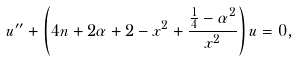Convert formula to latex. <formula><loc_0><loc_0><loc_500><loc_500>u ^ { \prime \prime } + \left ( 4 n + 2 \alpha + 2 - x ^ { 2 } + \frac { \frac { 1 } { 4 } - \alpha ^ { 2 } } { x ^ { 2 } } \right ) u = 0 ,</formula> 